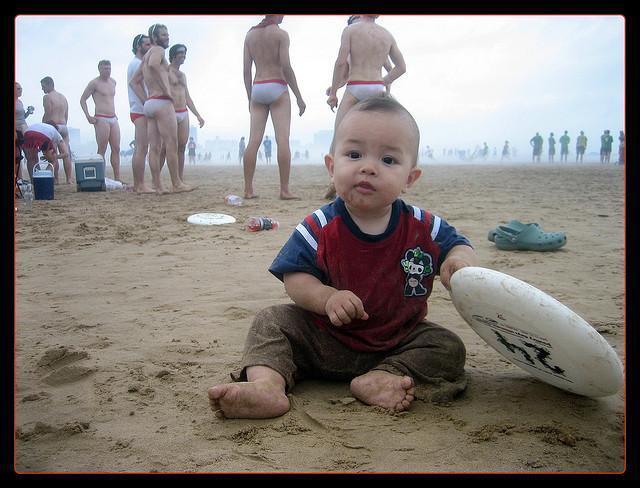How many people are in the picture?
Give a very brief answer. 5. How many frisbees are in the photo?
Give a very brief answer. 1. 